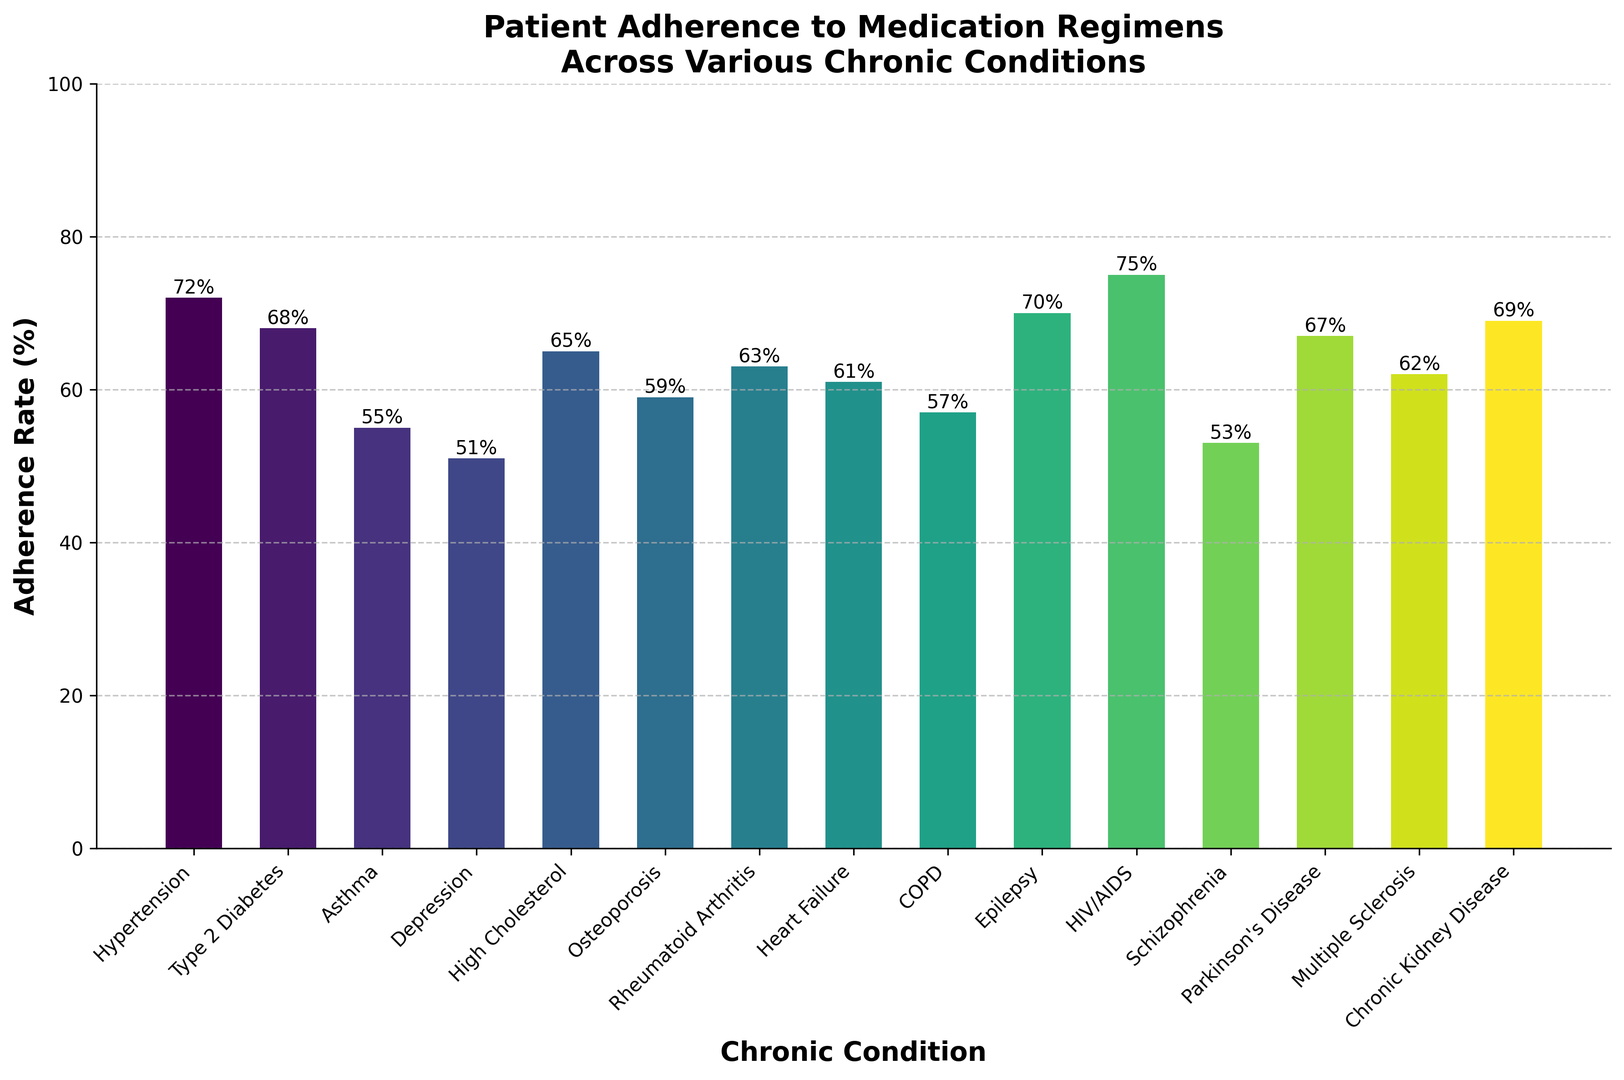Which condition has the highest adherence rate? To determine the highest adherence rate, look at the tallest bar in the figure. The condition corresponding to this bar is HIV/AIDS.
Answer: HIV/AIDS What is the difference in adherence rates between Hypertension and Asthma? Hypertension has an adherence rate of 72%, and Asthma has 55%. The difference is calculated as 72% - 55% = 17%.
Answer: 17% Which two conditions have the closest adherence rates? The conditions with the closest adherence rates can be found by comparing the values. Rheumatoid Arthritis (63%) and Multiple Sclerosis (62%) have a 1% difference.
Answer: Rheumatoid Arthritis and Multiple Sclerosis What is the average adherence rate of all the conditions? Add all the adherence rates and divide by the number of conditions: (72 + 68 + 55 + 51 + 65 + 59 + 63 + 61 + 57 + 70 + 75 + 53 + 67 + 62 + 69) / 15 = 63.2%.
Answer: 63.2% Which condition has a higher adherence rate: Depression or Schizophrenia? Compare the heights of the bars for Depression and Schizophrenia. Depression has an adherence rate of 51%, and Schizophrenia has 53%.
Answer: Schizophrenia Is the adherence rate for Chronic Kidney Disease greater than 60%? Look at the bar representing Chronic Kidney Disease. Its adherence rate is 69%, which is greater than 60%.
Answer: Yes What is the range of the adherence rates across all conditions? The range is the difference between the highest and lowest adherence rates: 75% (HIV/AIDS) - 51% (Depression) = 24%.
Answer: 24% Which condition has the second-highest adherence rate? Identify the highest adherence rate first (HIV/AIDS, 75%), then the next highest: 72% (Hypertension).
Answer: Hypertension Out of Epilepsy, High Cholesterol, and Heart Failure, which has the lowest adherence rate? Compare the adherence rates: Epilepsy (70%), High Cholesterol (65%), and Heart Failure (61%). Heart Failure has the lowest.
Answer: Heart Failure What is the median adherence rate of the conditions? To find the median, list the adherence rates in ascending order and find the middle value: 51, 53, 55, 57, 59, 61, 62, 63, 65, 67, 68, 69, 70, 72, 75. The median (middle) value is 63%.
Answer: 63% 